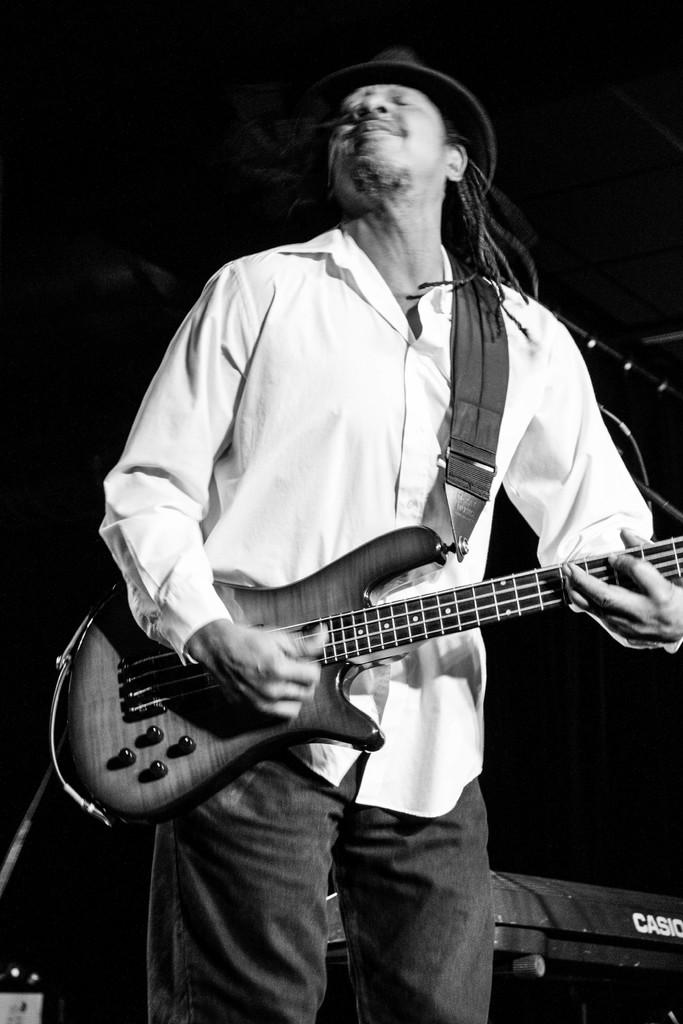What is the main subject of the image? There is a man in the image. What is the man holding in the image? The man is holding a guitar. What might the man be doing with the guitar? The man is likely playing the guitar. What type of crack can be seen in the image? There is no crack present in the image. Are there any cacti visible in the image? There is no mention of cacti in the provided facts, so it cannot be determined if they are present in the image. 